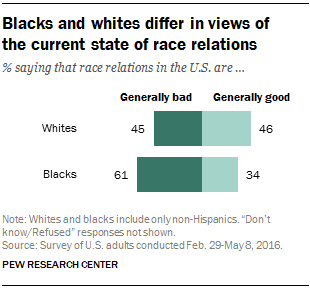List a handful of essential elements in this visual. There are two colors in the bar. According to the data, a majority of respondents, regardless of racial background, hold a negative view of whites and blacks as a group. 